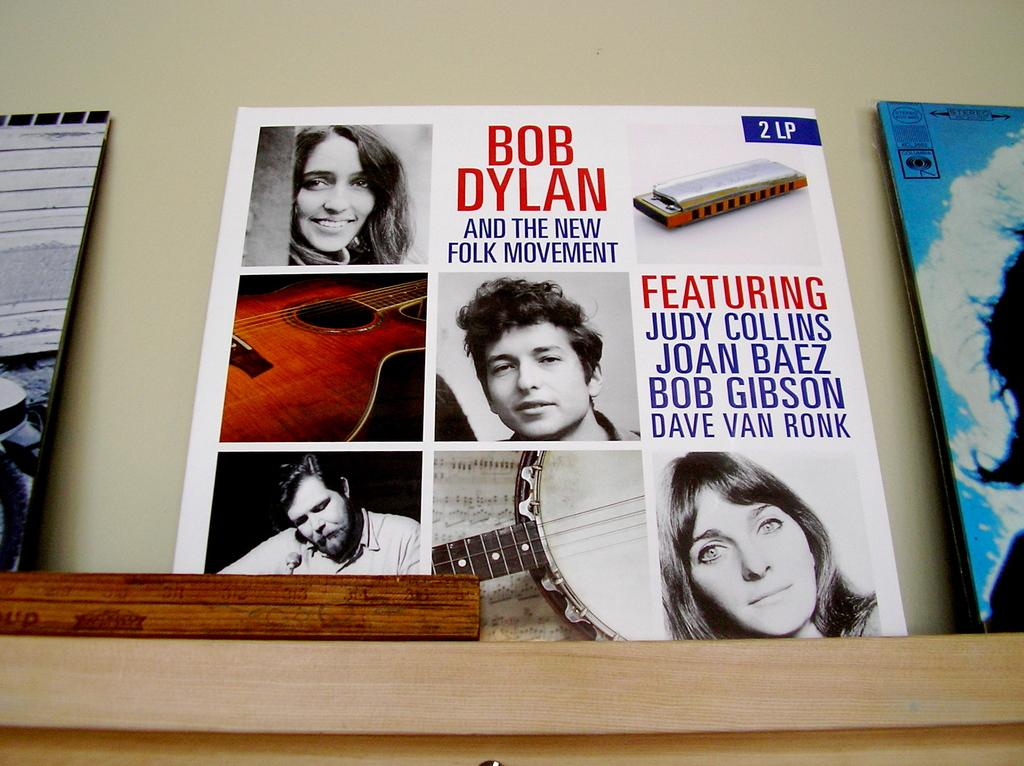<image>
Relay a brief, clear account of the picture shown. A Bob Dylan Album is displayed on a shelf, between two other albums. 